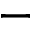<formula> <loc_0><loc_0><loc_500><loc_500>-</formula> 